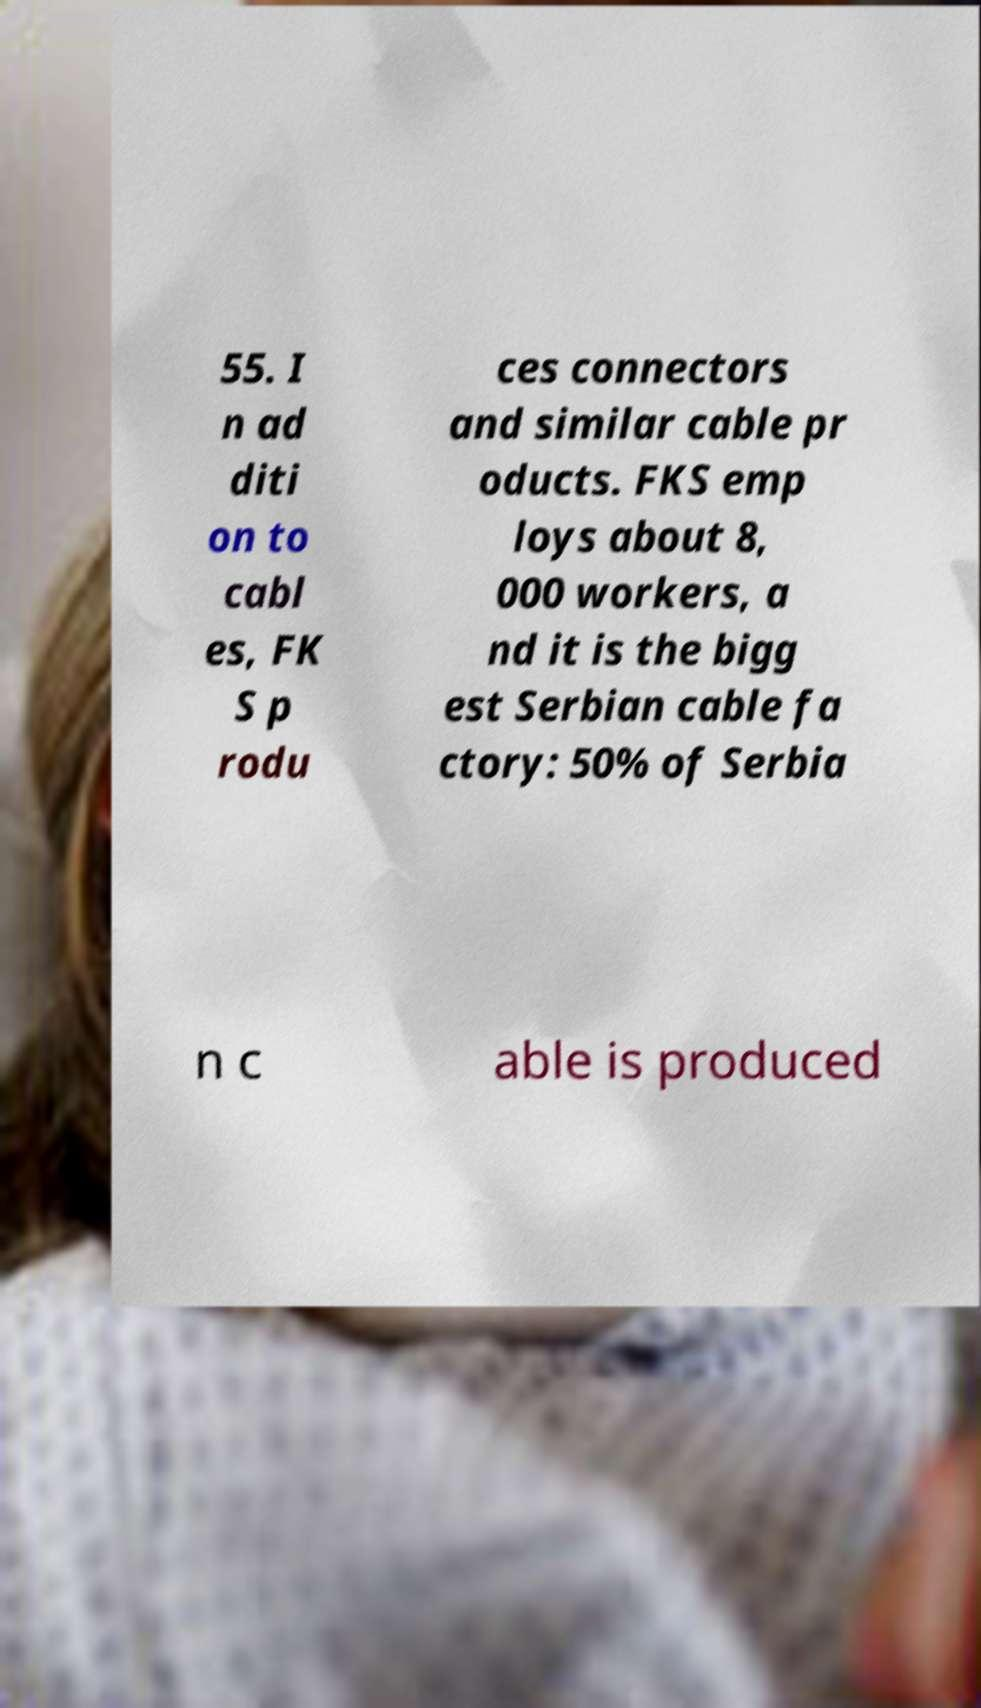Can you read and provide the text displayed in the image?This photo seems to have some interesting text. Can you extract and type it out for me? 55. I n ad diti on to cabl es, FK S p rodu ces connectors and similar cable pr oducts. FKS emp loys about 8, 000 workers, a nd it is the bigg est Serbian cable fa ctory: 50% of Serbia n c able is produced 